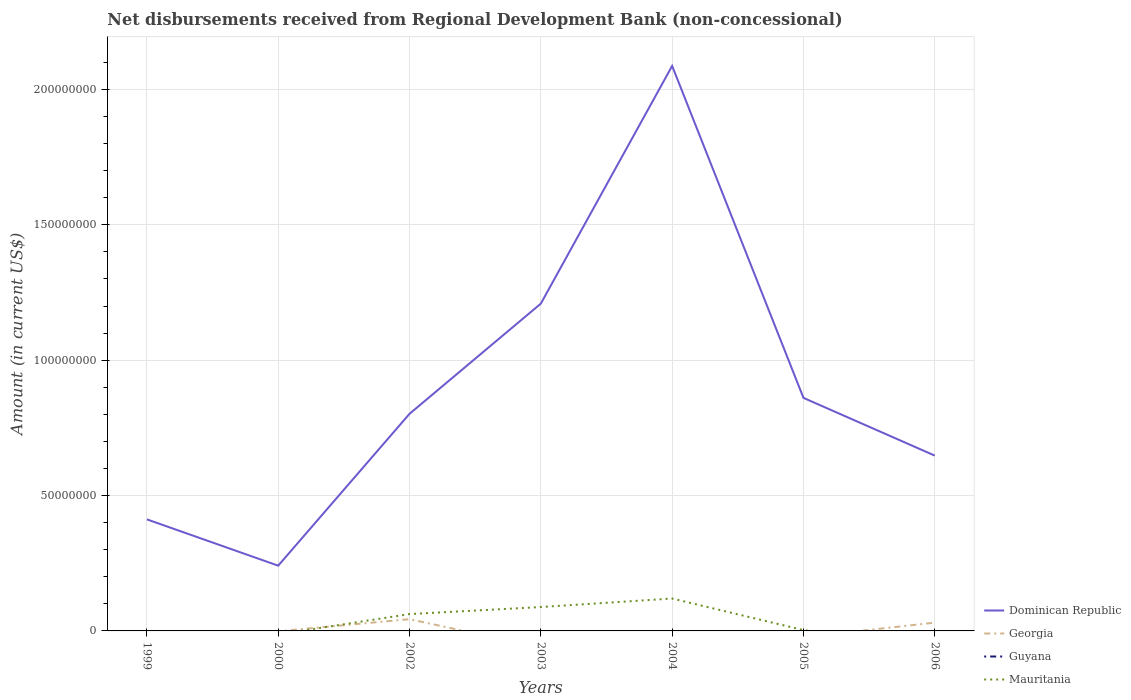How many different coloured lines are there?
Provide a succinct answer. 3. Does the line corresponding to Guyana intersect with the line corresponding to Georgia?
Ensure brevity in your answer.  Yes. What is the total amount of disbursements received from Regional Development Bank in Dominican Republic in the graph?
Ensure brevity in your answer.  1.71e+07. What is the difference between the highest and the second highest amount of disbursements received from Regional Development Bank in Mauritania?
Ensure brevity in your answer.  1.20e+07. Is the amount of disbursements received from Regional Development Bank in Georgia strictly greater than the amount of disbursements received from Regional Development Bank in Mauritania over the years?
Your answer should be compact. No. How many years are there in the graph?
Your answer should be very brief. 7. Are the values on the major ticks of Y-axis written in scientific E-notation?
Your answer should be very brief. No. Where does the legend appear in the graph?
Make the answer very short. Bottom right. What is the title of the graph?
Offer a very short reply. Net disbursements received from Regional Development Bank (non-concessional). What is the label or title of the X-axis?
Offer a very short reply. Years. What is the Amount (in current US$) of Dominican Republic in 1999?
Provide a short and direct response. 4.12e+07. What is the Amount (in current US$) of Georgia in 1999?
Your answer should be compact. 0. What is the Amount (in current US$) of Dominican Republic in 2000?
Give a very brief answer. 2.41e+07. What is the Amount (in current US$) in Georgia in 2000?
Offer a very short reply. 0. What is the Amount (in current US$) in Guyana in 2000?
Keep it short and to the point. 0. What is the Amount (in current US$) in Dominican Republic in 2002?
Give a very brief answer. 8.02e+07. What is the Amount (in current US$) in Georgia in 2002?
Provide a succinct answer. 4.34e+06. What is the Amount (in current US$) of Mauritania in 2002?
Offer a very short reply. 6.22e+06. What is the Amount (in current US$) of Dominican Republic in 2003?
Keep it short and to the point. 1.21e+08. What is the Amount (in current US$) in Guyana in 2003?
Give a very brief answer. 0. What is the Amount (in current US$) in Mauritania in 2003?
Your answer should be very brief. 8.82e+06. What is the Amount (in current US$) of Dominican Republic in 2004?
Provide a succinct answer. 2.09e+08. What is the Amount (in current US$) in Georgia in 2004?
Provide a succinct answer. 0. What is the Amount (in current US$) in Mauritania in 2004?
Offer a terse response. 1.20e+07. What is the Amount (in current US$) of Dominican Republic in 2005?
Provide a short and direct response. 8.61e+07. What is the Amount (in current US$) in Guyana in 2005?
Offer a very short reply. 0. What is the Amount (in current US$) of Mauritania in 2005?
Ensure brevity in your answer.  2.94e+05. What is the Amount (in current US$) in Dominican Republic in 2006?
Keep it short and to the point. 6.47e+07. What is the Amount (in current US$) of Georgia in 2006?
Offer a very short reply. 3.06e+06. What is the Amount (in current US$) of Mauritania in 2006?
Keep it short and to the point. 0. Across all years, what is the maximum Amount (in current US$) of Dominican Republic?
Your answer should be very brief. 2.09e+08. Across all years, what is the maximum Amount (in current US$) of Georgia?
Make the answer very short. 4.34e+06. Across all years, what is the maximum Amount (in current US$) in Mauritania?
Provide a succinct answer. 1.20e+07. Across all years, what is the minimum Amount (in current US$) of Dominican Republic?
Keep it short and to the point. 2.41e+07. Across all years, what is the minimum Amount (in current US$) in Georgia?
Make the answer very short. 0. What is the total Amount (in current US$) in Dominican Republic in the graph?
Your answer should be compact. 6.26e+08. What is the total Amount (in current US$) of Georgia in the graph?
Provide a succinct answer. 7.40e+06. What is the total Amount (in current US$) of Guyana in the graph?
Make the answer very short. 0. What is the total Amount (in current US$) in Mauritania in the graph?
Your response must be concise. 2.73e+07. What is the difference between the Amount (in current US$) in Dominican Republic in 1999 and that in 2000?
Provide a succinct answer. 1.71e+07. What is the difference between the Amount (in current US$) in Dominican Republic in 1999 and that in 2002?
Your answer should be compact. -3.90e+07. What is the difference between the Amount (in current US$) of Dominican Republic in 1999 and that in 2003?
Your response must be concise. -7.97e+07. What is the difference between the Amount (in current US$) of Dominican Republic in 1999 and that in 2004?
Your answer should be very brief. -1.67e+08. What is the difference between the Amount (in current US$) in Dominican Republic in 1999 and that in 2005?
Your answer should be very brief. -4.49e+07. What is the difference between the Amount (in current US$) of Dominican Republic in 1999 and that in 2006?
Provide a short and direct response. -2.35e+07. What is the difference between the Amount (in current US$) of Dominican Republic in 2000 and that in 2002?
Ensure brevity in your answer.  -5.61e+07. What is the difference between the Amount (in current US$) of Dominican Republic in 2000 and that in 2003?
Your response must be concise. -9.68e+07. What is the difference between the Amount (in current US$) of Dominican Republic in 2000 and that in 2004?
Your answer should be compact. -1.85e+08. What is the difference between the Amount (in current US$) of Dominican Republic in 2000 and that in 2005?
Make the answer very short. -6.20e+07. What is the difference between the Amount (in current US$) in Dominican Republic in 2000 and that in 2006?
Give a very brief answer. -4.06e+07. What is the difference between the Amount (in current US$) in Dominican Republic in 2002 and that in 2003?
Provide a short and direct response. -4.07e+07. What is the difference between the Amount (in current US$) in Mauritania in 2002 and that in 2003?
Your answer should be very brief. -2.60e+06. What is the difference between the Amount (in current US$) in Dominican Republic in 2002 and that in 2004?
Your response must be concise. -1.28e+08. What is the difference between the Amount (in current US$) of Mauritania in 2002 and that in 2004?
Your answer should be very brief. -5.74e+06. What is the difference between the Amount (in current US$) of Dominican Republic in 2002 and that in 2005?
Make the answer very short. -5.88e+06. What is the difference between the Amount (in current US$) in Mauritania in 2002 and that in 2005?
Ensure brevity in your answer.  5.93e+06. What is the difference between the Amount (in current US$) in Dominican Republic in 2002 and that in 2006?
Provide a succinct answer. 1.54e+07. What is the difference between the Amount (in current US$) of Georgia in 2002 and that in 2006?
Your answer should be compact. 1.28e+06. What is the difference between the Amount (in current US$) of Dominican Republic in 2003 and that in 2004?
Provide a short and direct response. -8.78e+07. What is the difference between the Amount (in current US$) of Mauritania in 2003 and that in 2004?
Keep it short and to the point. -3.14e+06. What is the difference between the Amount (in current US$) of Dominican Republic in 2003 and that in 2005?
Give a very brief answer. 3.48e+07. What is the difference between the Amount (in current US$) in Mauritania in 2003 and that in 2005?
Keep it short and to the point. 8.53e+06. What is the difference between the Amount (in current US$) of Dominican Republic in 2003 and that in 2006?
Offer a very short reply. 5.61e+07. What is the difference between the Amount (in current US$) in Dominican Republic in 2004 and that in 2005?
Your response must be concise. 1.23e+08. What is the difference between the Amount (in current US$) of Mauritania in 2004 and that in 2005?
Your answer should be very brief. 1.17e+07. What is the difference between the Amount (in current US$) of Dominican Republic in 2004 and that in 2006?
Make the answer very short. 1.44e+08. What is the difference between the Amount (in current US$) of Dominican Republic in 2005 and that in 2006?
Ensure brevity in your answer.  2.13e+07. What is the difference between the Amount (in current US$) in Dominican Republic in 1999 and the Amount (in current US$) in Georgia in 2002?
Keep it short and to the point. 3.69e+07. What is the difference between the Amount (in current US$) of Dominican Republic in 1999 and the Amount (in current US$) of Mauritania in 2002?
Provide a short and direct response. 3.50e+07. What is the difference between the Amount (in current US$) of Dominican Republic in 1999 and the Amount (in current US$) of Mauritania in 2003?
Ensure brevity in your answer.  3.24e+07. What is the difference between the Amount (in current US$) of Dominican Republic in 1999 and the Amount (in current US$) of Mauritania in 2004?
Your response must be concise. 2.92e+07. What is the difference between the Amount (in current US$) of Dominican Republic in 1999 and the Amount (in current US$) of Mauritania in 2005?
Your answer should be compact. 4.09e+07. What is the difference between the Amount (in current US$) in Dominican Republic in 1999 and the Amount (in current US$) in Georgia in 2006?
Make the answer very short. 3.81e+07. What is the difference between the Amount (in current US$) in Dominican Republic in 2000 and the Amount (in current US$) in Georgia in 2002?
Offer a terse response. 1.98e+07. What is the difference between the Amount (in current US$) in Dominican Republic in 2000 and the Amount (in current US$) in Mauritania in 2002?
Your answer should be compact. 1.79e+07. What is the difference between the Amount (in current US$) of Dominican Republic in 2000 and the Amount (in current US$) of Mauritania in 2003?
Your response must be concise. 1.53e+07. What is the difference between the Amount (in current US$) of Dominican Republic in 2000 and the Amount (in current US$) of Mauritania in 2004?
Offer a terse response. 1.21e+07. What is the difference between the Amount (in current US$) in Dominican Republic in 2000 and the Amount (in current US$) in Mauritania in 2005?
Ensure brevity in your answer.  2.38e+07. What is the difference between the Amount (in current US$) in Dominican Republic in 2000 and the Amount (in current US$) in Georgia in 2006?
Provide a succinct answer. 2.10e+07. What is the difference between the Amount (in current US$) of Dominican Republic in 2002 and the Amount (in current US$) of Mauritania in 2003?
Your answer should be very brief. 7.14e+07. What is the difference between the Amount (in current US$) in Georgia in 2002 and the Amount (in current US$) in Mauritania in 2003?
Your answer should be very brief. -4.48e+06. What is the difference between the Amount (in current US$) of Dominican Republic in 2002 and the Amount (in current US$) of Mauritania in 2004?
Keep it short and to the point. 6.82e+07. What is the difference between the Amount (in current US$) of Georgia in 2002 and the Amount (in current US$) of Mauritania in 2004?
Your answer should be very brief. -7.63e+06. What is the difference between the Amount (in current US$) in Dominican Republic in 2002 and the Amount (in current US$) in Mauritania in 2005?
Provide a succinct answer. 7.99e+07. What is the difference between the Amount (in current US$) in Georgia in 2002 and the Amount (in current US$) in Mauritania in 2005?
Offer a terse response. 4.05e+06. What is the difference between the Amount (in current US$) in Dominican Republic in 2002 and the Amount (in current US$) in Georgia in 2006?
Give a very brief answer. 7.71e+07. What is the difference between the Amount (in current US$) of Dominican Republic in 2003 and the Amount (in current US$) of Mauritania in 2004?
Provide a succinct answer. 1.09e+08. What is the difference between the Amount (in current US$) in Dominican Republic in 2003 and the Amount (in current US$) in Mauritania in 2005?
Give a very brief answer. 1.21e+08. What is the difference between the Amount (in current US$) in Dominican Republic in 2003 and the Amount (in current US$) in Georgia in 2006?
Offer a terse response. 1.18e+08. What is the difference between the Amount (in current US$) in Dominican Republic in 2004 and the Amount (in current US$) in Mauritania in 2005?
Offer a very short reply. 2.08e+08. What is the difference between the Amount (in current US$) of Dominican Republic in 2004 and the Amount (in current US$) of Georgia in 2006?
Ensure brevity in your answer.  2.06e+08. What is the difference between the Amount (in current US$) in Dominican Republic in 2005 and the Amount (in current US$) in Georgia in 2006?
Your answer should be compact. 8.30e+07. What is the average Amount (in current US$) of Dominican Republic per year?
Give a very brief answer. 8.94e+07. What is the average Amount (in current US$) of Georgia per year?
Your answer should be compact. 1.06e+06. What is the average Amount (in current US$) in Guyana per year?
Provide a succinct answer. 0. What is the average Amount (in current US$) in Mauritania per year?
Provide a short and direct response. 3.90e+06. In the year 2002, what is the difference between the Amount (in current US$) in Dominican Republic and Amount (in current US$) in Georgia?
Make the answer very short. 7.58e+07. In the year 2002, what is the difference between the Amount (in current US$) in Dominican Republic and Amount (in current US$) in Mauritania?
Ensure brevity in your answer.  7.40e+07. In the year 2002, what is the difference between the Amount (in current US$) of Georgia and Amount (in current US$) of Mauritania?
Provide a short and direct response. -1.88e+06. In the year 2003, what is the difference between the Amount (in current US$) of Dominican Republic and Amount (in current US$) of Mauritania?
Keep it short and to the point. 1.12e+08. In the year 2004, what is the difference between the Amount (in current US$) in Dominican Republic and Amount (in current US$) in Mauritania?
Your answer should be compact. 1.97e+08. In the year 2005, what is the difference between the Amount (in current US$) of Dominican Republic and Amount (in current US$) of Mauritania?
Make the answer very short. 8.58e+07. In the year 2006, what is the difference between the Amount (in current US$) of Dominican Republic and Amount (in current US$) of Georgia?
Ensure brevity in your answer.  6.17e+07. What is the ratio of the Amount (in current US$) in Dominican Republic in 1999 to that in 2000?
Make the answer very short. 1.71. What is the ratio of the Amount (in current US$) in Dominican Republic in 1999 to that in 2002?
Offer a very short reply. 0.51. What is the ratio of the Amount (in current US$) of Dominican Republic in 1999 to that in 2003?
Make the answer very short. 0.34. What is the ratio of the Amount (in current US$) of Dominican Republic in 1999 to that in 2004?
Give a very brief answer. 0.2. What is the ratio of the Amount (in current US$) of Dominican Republic in 1999 to that in 2005?
Your response must be concise. 0.48. What is the ratio of the Amount (in current US$) in Dominican Republic in 1999 to that in 2006?
Offer a terse response. 0.64. What is the ratio of the Amount (in current US$) in Dominican Republic in 2000 to that in 2002?
Provide a succinct answer. 0.3. What is the ratio of the Amount (in current US$) of Dominican Republic in 2000 to that in 2003?
Offer a terse response. 0.2. What is the ratio of the Amount (in current US$) in Dominican Republic in 2000 to that in 2004?
Your answer should be compact. 0.12. What is the ratio of the Amount (in current US$) of Dominican Republic in 2000 to that in 2005?
Your answer should be very brief. 0.28. What is the ratio of the Amount (in current US$) in Dominican Republic in 2000 to that in 2006?
Keep it short and to the point. 0.37. What is the ratio of the Amount (in current US$) in Dominican Republic in 2002 to that in 2003?
Provide a short and direct response. 0.66. What is the ratio of the Amount (in current US$) in Mauritania in 2002 to that in 2003?
Offer a very short reply. 0.71. What is the ratio of the Amount (in current US$) in Dominican Republic in 2002 to that in 2004?
Your answer should be compact. 0.38. What is the ratio of the Amount (in current US$) of Mauritania in 2002 to that in 2004?
Keep it short and to the point. 0.52. What is the ratio of the Amount (in current US$) of Dominican Republic in 2002 to that in 2005?
Provide a succinct answer. 0.93. What is the ratio of the Amount (in current US$) in Mauritania in 2002 to that in 2005?
Offer a very short reply. 21.16. What is the ratio of the Amount (in current US$) in Dominican Republic in 2002 to that in 2006?
Make the answer very short. 1.24. What is the ratio of the Amount (in current US$) of Georgia in 2002 to that in 2006?
Keep it short and to the point. 1.42. What is the ratio of the Amount (in current US$) of Dominican Republic in 2003 to that in 2004?
Your answer should be very brief. 0.58. What is the ratio of the Amount (in current US$) of Mauritania in 2003 to that in 2004?
Make the answer very short. 0.74. What is the ratio of the Amount (in current US$) of Dominican Republic in 2003 to that in 2005?
Your answer should be compact. 1.4. What is the ratio of the Amount (in current US$) of Mauritania in 2003 to that in 2005?
Provide a short and direct response. 30.01. What is the ratio of the Amount (in current US$) of Dominican Republic in 2003 to that in 2006?
Give a very brief answer. 1.87. What is the ratio of the Amount (in current US$) of Dominican Republic in 2004 to that in 2005?
Keep it short and to the point. 2.42. What is the ratio of the Amount (in current US$) in Mauritania in 2004 to that in 2005?
Make the answer very short. 40.7. What is the ratio of the Amount (in current US$) in Dominican Republic in 2004 to that in 2006?
Offer a terse response. 3.22. What is the ratio of the Amount (in current US$) in Dominican Republic in 2005 to that in 2006?
Keep it short and to the point. 1.33. What is the difference between the highest and the second highest Amount (in current US$) of Dominican Republic?
Offer a terse response. 8.78e+07. What is the difference between the highest and the second highest Amount (in current US$) in Mauritania?
Offer a terse response. 3.14e+06. What is the difference between the highest and the lowest Amount (in current US$) of Dominican Republic?
Provide a succinct answer. 1.85e+08. What is the difference between the highest and the lowest Amount (in current US$) of Georgia?
Your response must be concise. 4.34e+06. What is the difference between the highest and the lowest Amount (in current US$) in Mauritania?
Give a very brief answer. 1.20e+07. 